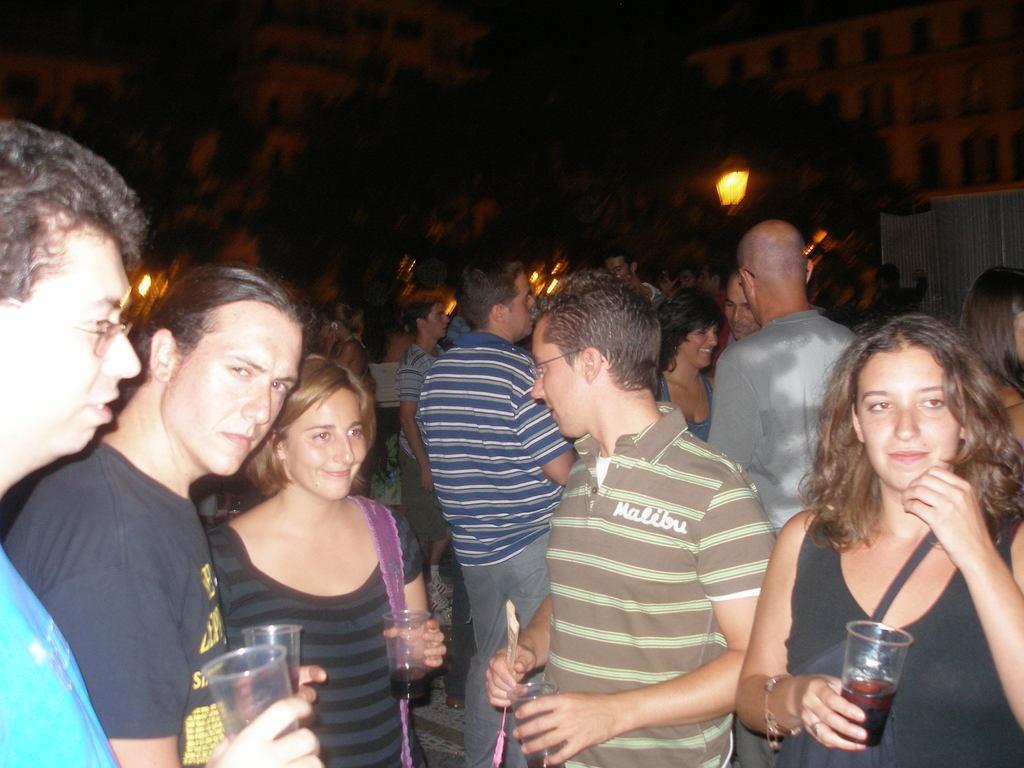How would you summarize this image in a sentence or two? In this image we can see there are people standing and holding a glass. And at the back we can see the building and tree. 